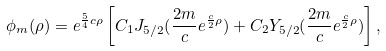<formula> <loc_0><loc_0><loc_500><loc_500>\phi _ { m } ( \rho ) = e ^ { \frac { 5 } { 4 } c \rho } \left [ C _ { 1 } J _ { 5 / 2 } ( \frac { 2 m } { c } e ^ { \frac { c } { 2 } \rho } ) + C _ { 2 } Y _ { 5 / 2 } ( \frac { 2 m } { c } e ^ { \frac { c } { 2 } \rho } ) \right ] ,</formula> 